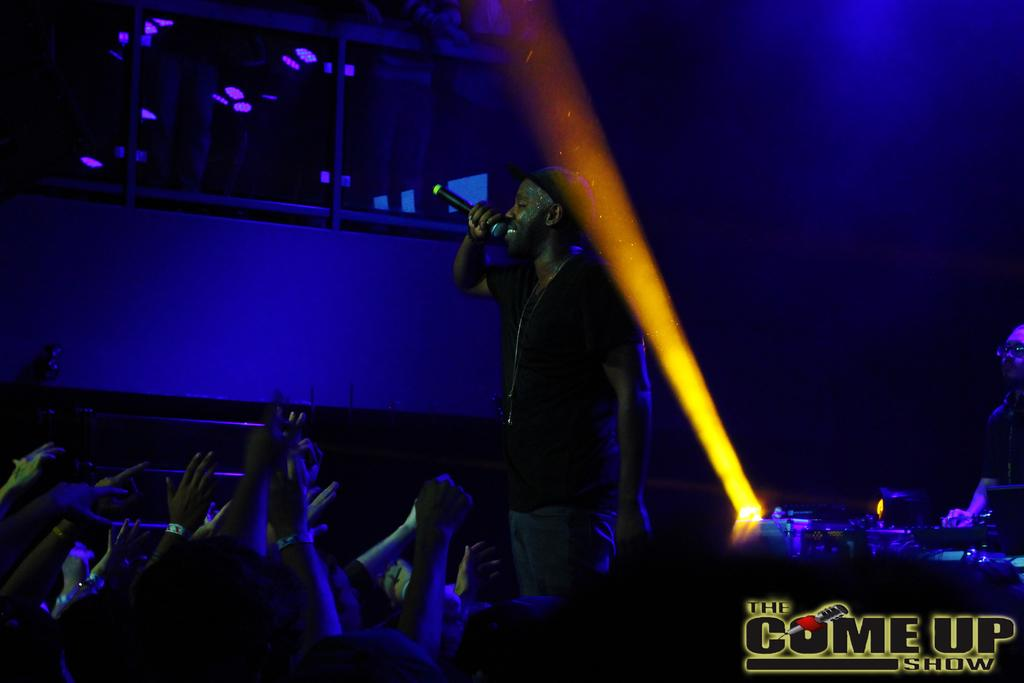What is the man in the image doing? The man is singing in the image. What is the man holding while singing? The man is holding a microphone. Who else is present in the image besides the man? There is a group of people in the image. What can be observed about the background of the image? The background of the image is dark. What type of bird can be seen sleeping in the image? There is no bird present in the image, and therefore no bird can be seen sleeping. What type of laborer is visible in the image? There is no laborer present in the image. 